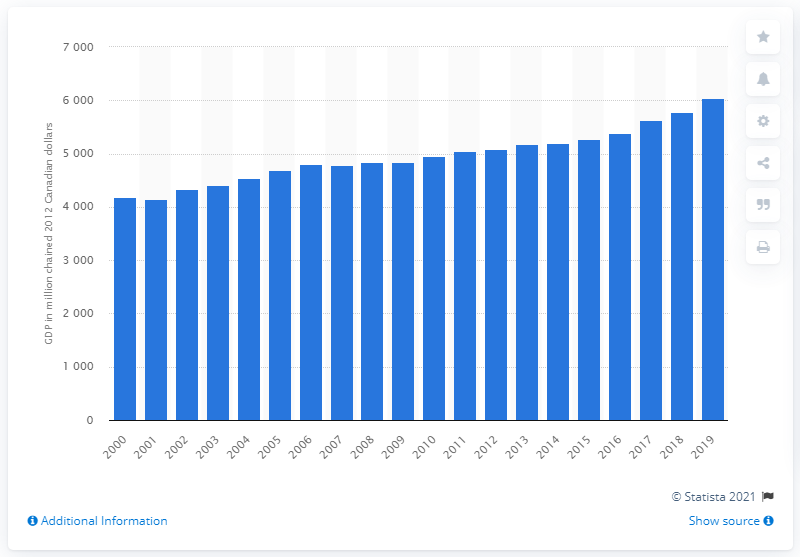Mention a couple of crucial points in this snapshot. In 2019, the Gross Domestic Product (GDP) of Prince Edward Island was $6052 million in current dollars. 